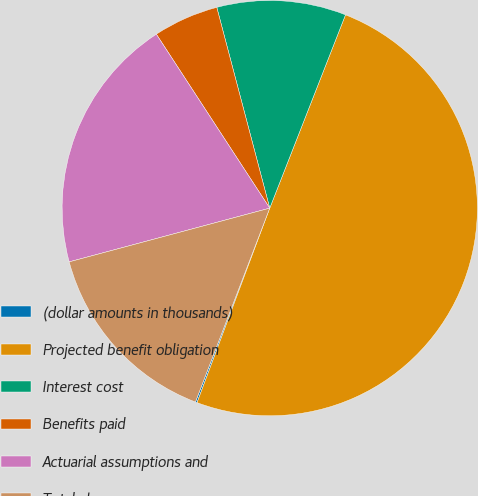<chart> <loc_0><loc_0><loc_500><loc_500><pie_chart><fcel>(dollar amounts in thousands)<fcel>Projected benefit obligation<fcel>Interest cost<fcel>Benefits paid<fcel>Actuarial assumptions and<fcel>Total changes<nl><fcel>0.13%<fcel>49.75%<fcel>10.05%<fcel>5.09%<fcel>19.97%<fcel>15.01%<nl></chart> 